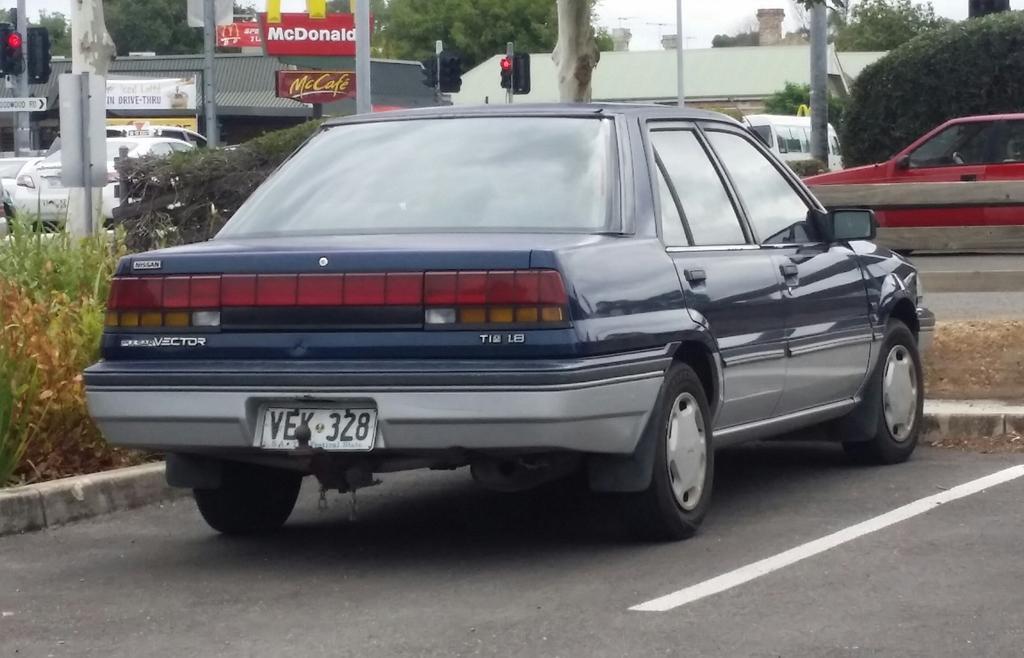In one or two sentences, can you explain what this image depicts? In this image I can see the ground, a car which is black in color on the ground, few plants, the road, few vehicles on the road, few poles, a traffic signal, few trees and few buildings. In the background I can see the sky. 